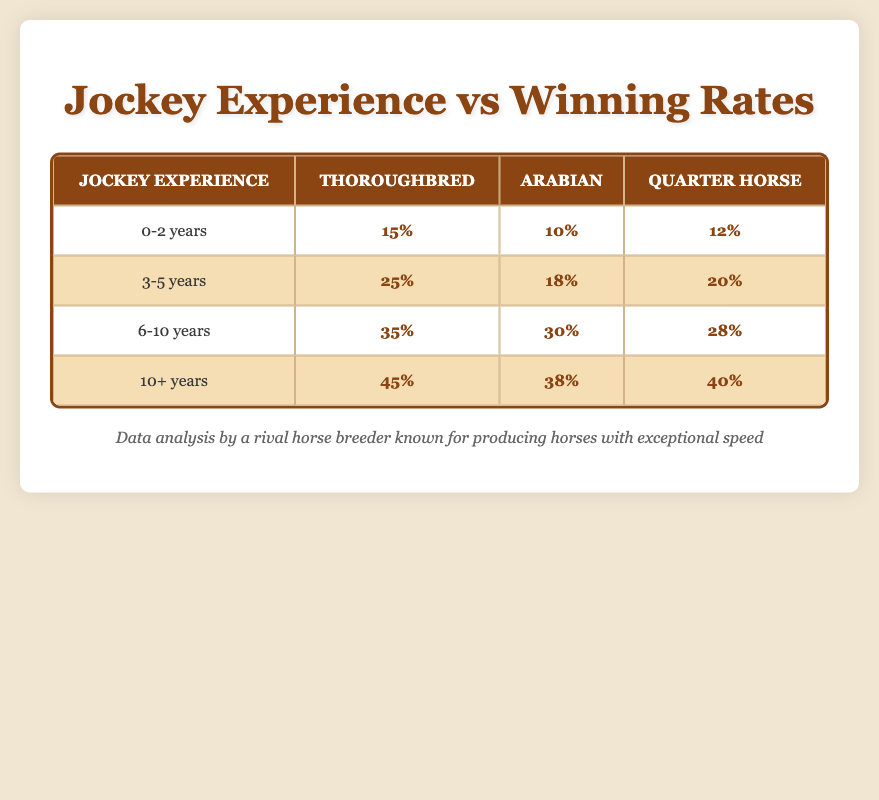What is the winning rate for Thoroughbreds ridden by jockeys with 10+ years of experience? According to the table, the winning rate for Thoroughbreds when jockeys have over ten years of experience is listed directly under the "Thoroughbred" column in the corresponding "10+ years" row. This value is 45%.
Answer: 45% Which horse breed has the lowest winning rate with jockeys who have 0-2 years of experience? To find the horse breed with the lowest winning rate for jockeys with 0-2 years of experience, we compare the values in that specific row: Thoroughbred (15%), Arabian (10%), and Quarter Horse (12%). The lowest winning rate is for the Arabian.
Answer: Arabian Calculate the average winning rate for Quarter Horses across all experience levels. To find the average winning rate for Quarter Horses, we sum the winning rates for this breed from each experience level: (12% + 20% + 28% + 40%) = 100%. Then, we divide by the number of experience levels, which is 4: 100% / 4 = 25%.
Answer: 25% Is it true that jockeys with 3-5 years of experience have a higher winning rate on Quarter Horses than those with 0-2 years of experience? The winning rate for Quarter Horses with 3-5 years of experience is 20%, while the winning rate for Quarter Horses with 0-2 years of experience is 12%. Since 20% > 12%, the statement is true.
Answer: Yes What is the difference in winning rates between the highest (10+ years) and the lowest (0-2 years) for Arabians? For Arabians, the winning rate for jockeys with 10+ years is 38% and for those with 0-2 years is 10%. To find the difference, subtract the lower rate from the higher rate: 38% - 10% = 28%.
Answer: 28% 